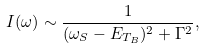<formula> <loc_0><loc_0><loc_500><loc_500>I ( \omega ) \sim \frac { 1 } { ( \omega _ { S } - E _ { T _ { B } } ) ^ { 2 } + \Gamma ^ { 2 } } ,</formula> 